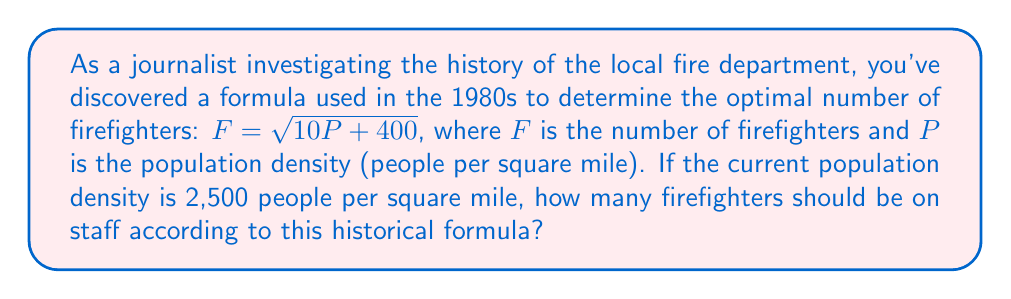Show me your answer to this math problem. To solve this problem, we'll follow these steps:

1. Identify the given information:
   - The formula: $F = \sqrt{10P + 400}$
   - Population density (P): 2,500 people per square mile

2. Substitute the population density into the formula:
   $F = \sqrt{10(2,500) + 400}$

3. Simplify the expression inside the square root:
   $F = \sqrt{25,000 + 400}$
   $F = \sqrt{25,400}$

4. Calculate the square root:
   $F = 159.37...$

5. Since we can't have a fractional number of firefighters, we round up to the nearest whole number:
   $F = 160$

Therefore, according to the historical formula, the fire department should have 160 firefighters on staff for a population density of 2,500 people per square mile.
Answer: 160 firefighters 